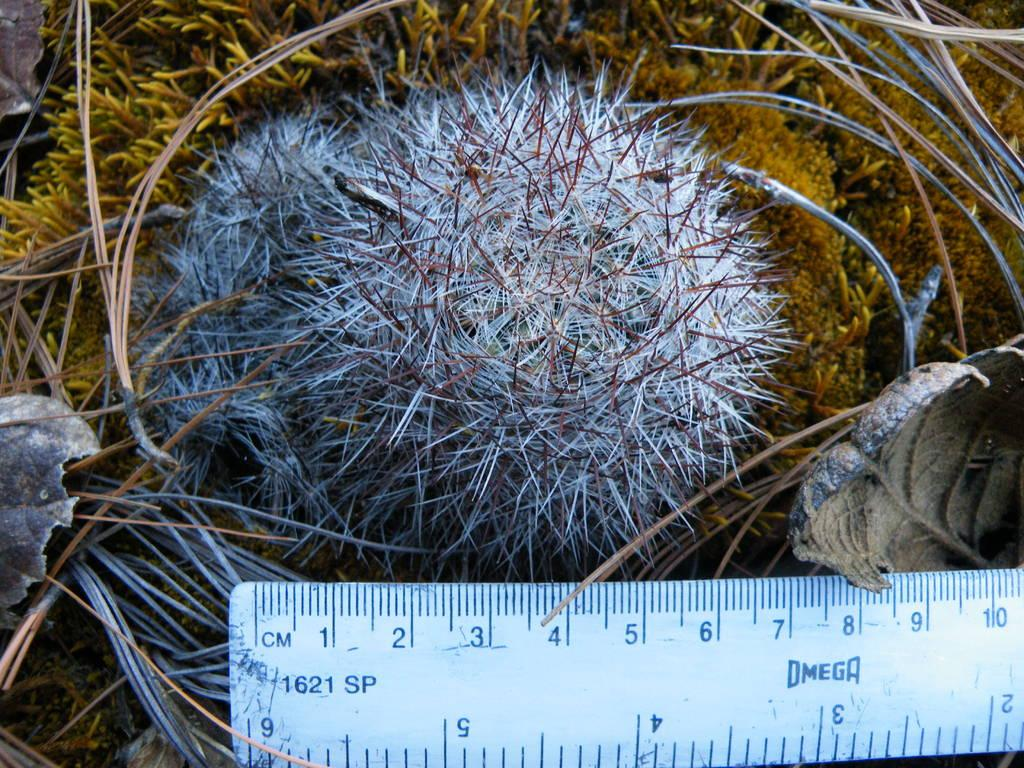Provide a one-sentence caption for the provided image. A round plant measures around 7 centimeters across. 